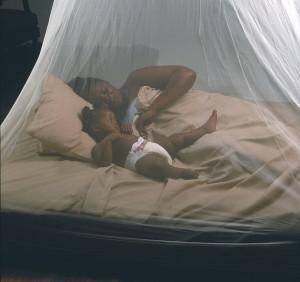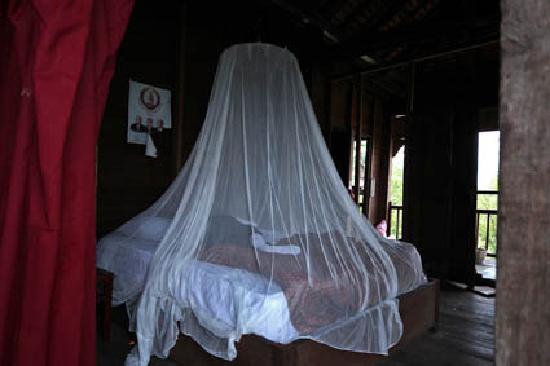The first image is the image on the left, the second image is the image on the right. Examine the images to the left and right. Is the description "The left and right image contains the same number of circle canopies." accurate? Answer yes or no. Yes. The first image is the image on the left, the second image is the image on the right. Examine the images to the left and right. Is the description "Each image shows a gauzy white canopy that suspends from above to surround a mattress, and at least one image shows two people lying under the canopy." accurate? Answer yes or no. Yes. 